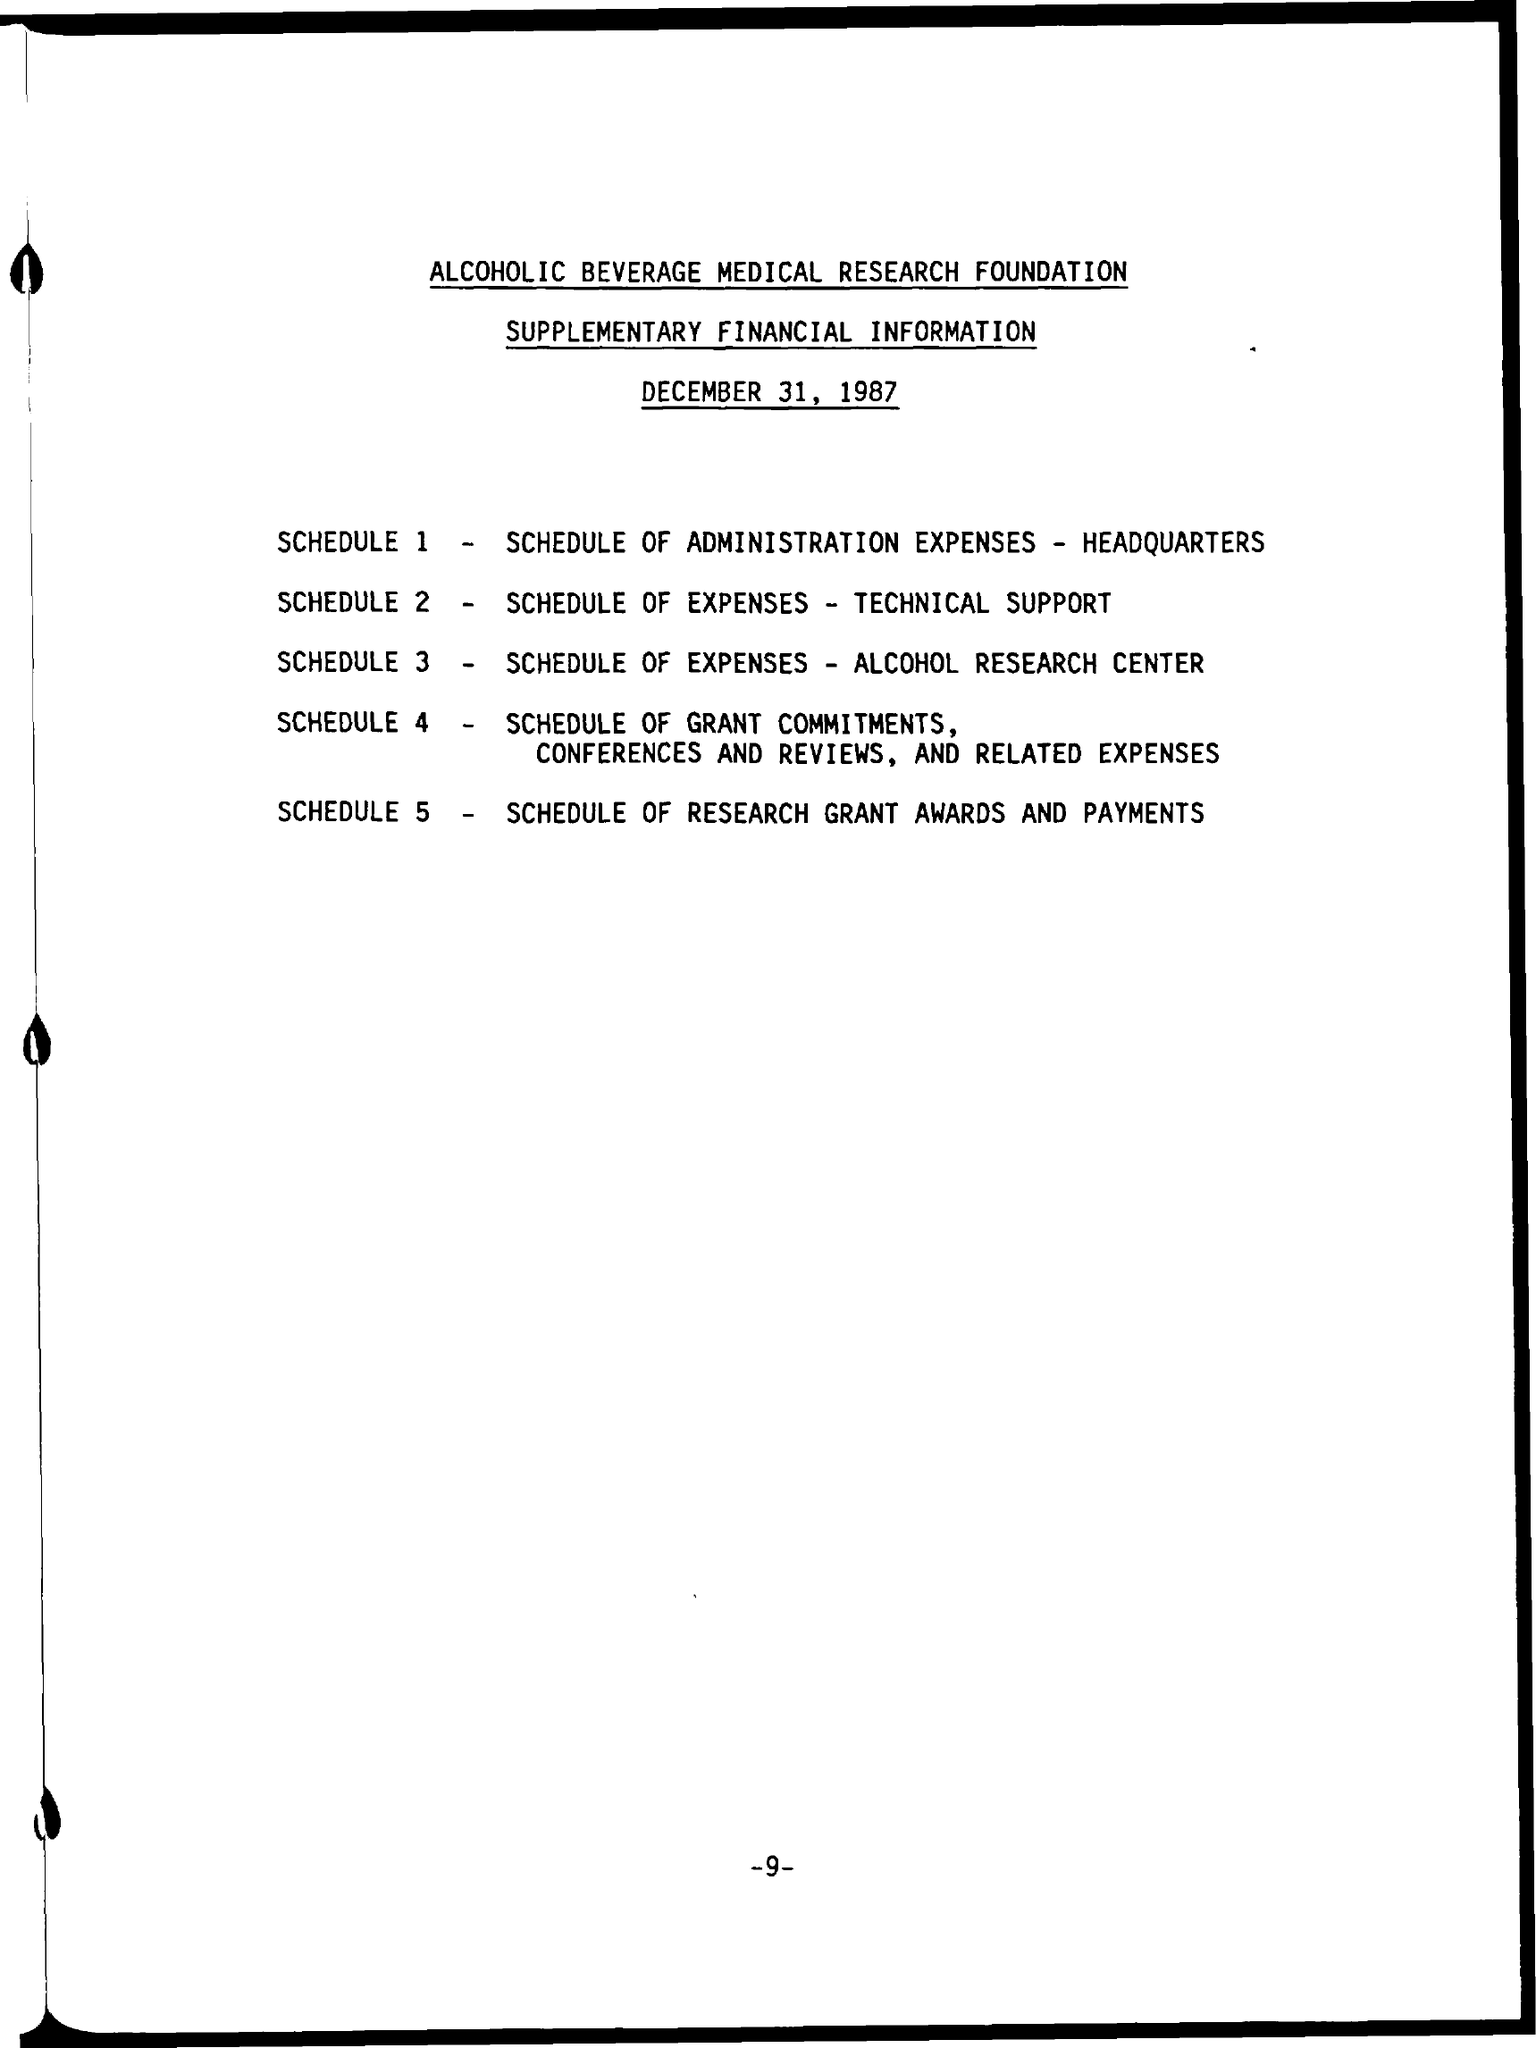What is the SCHEDULE 2?
Your answer should be very brief. Schedule of expenses - Technical Support. What is the SCHEDULE 3 ?
Give a very brief answer. Schedule of expenses - Alcohol Research center. What is the SCHEDULE 5 ?
Keep it short and to the point. Schedule of Research Grant, Awards and Payments. 